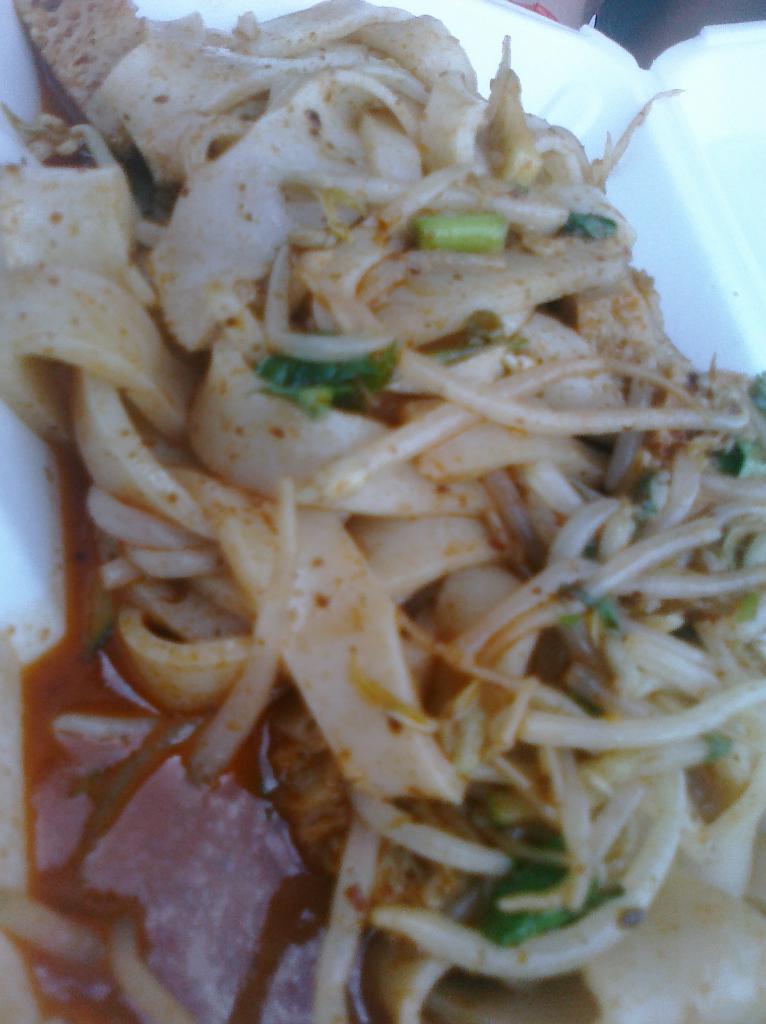How would you summarize this image in a sentence or two? In this image I can see the food in the white color box. Food is in cream, red and green color. 